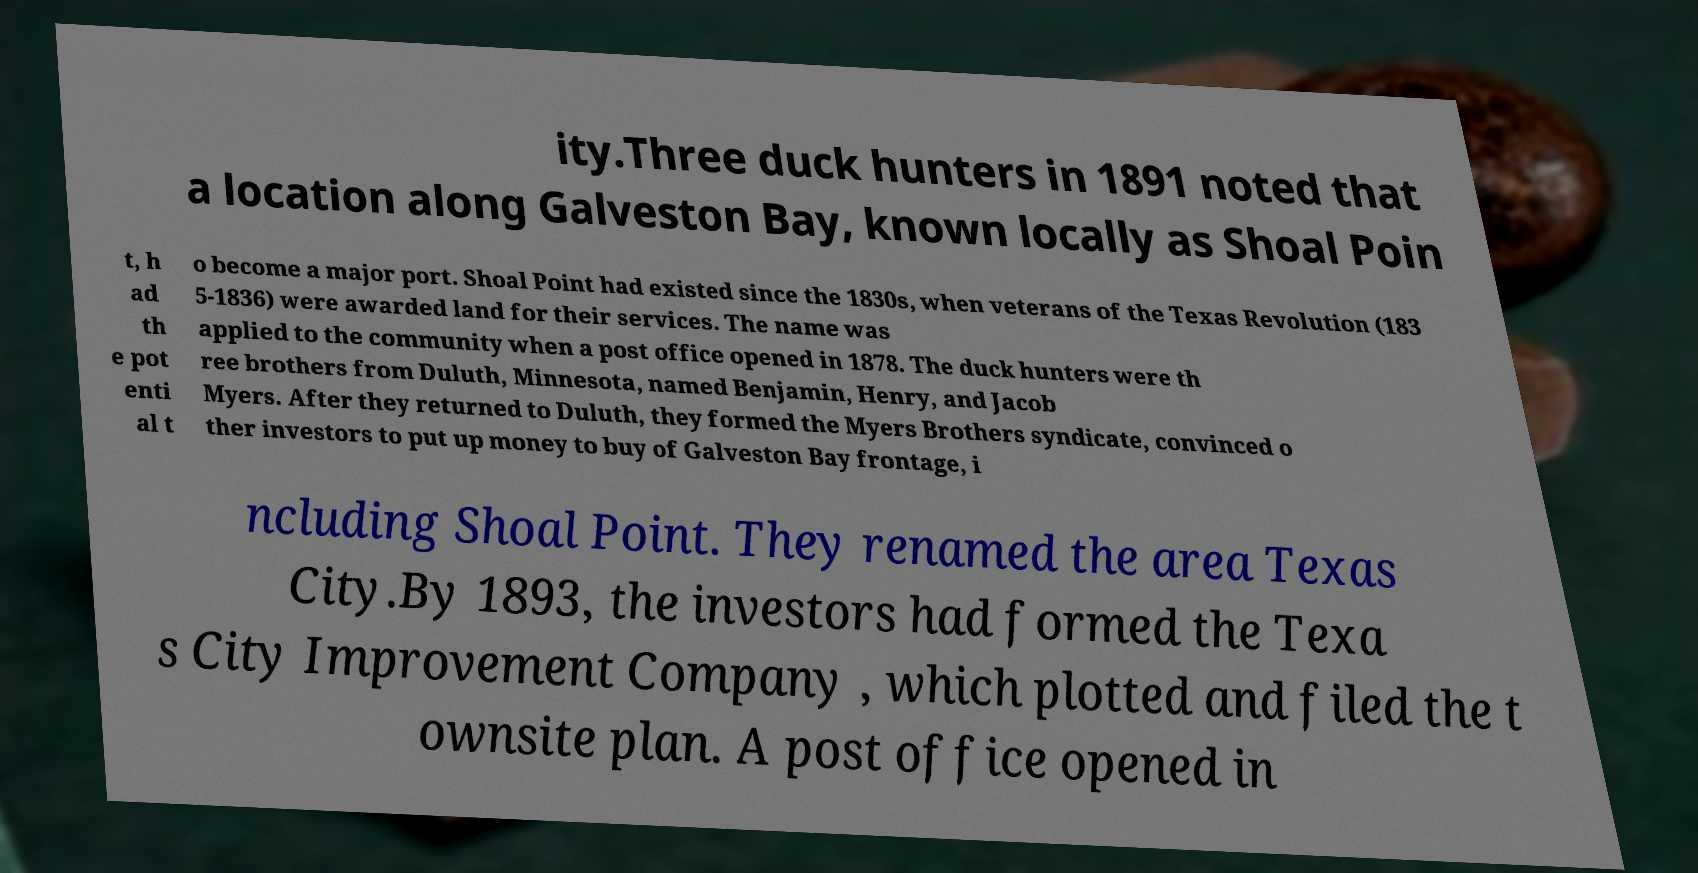For documentation purposes, I need the text within this image transcribed. Could you provide that? ity.Three duck hunters in 1891 noted that a location along Galveston Bay, known locally as Shoal Poin t, h ad th e pot enti al t o become a major port. Shoal Point had existed since the 1830s, when veterans of the Texas Revolution (183 5-1836) were awarded land for their services. The name was applied to the community when a post office opened in 1878. The duck hunters were th ree brothers from Duluth, Minnesota, named Benjamin, Henry, and Jacob Myers. After they returned to Duluth, they formed the Myers Brothers syndicate, convinced o ther investors to put up money to buy of Galveston Bay frontage, i ncluding Shoal Point. They renamed the area Texas City.By 1893, the investors had formed the Texa s City Improvement Company , which plotted and filed the t ownsite plan. A post office opened in 